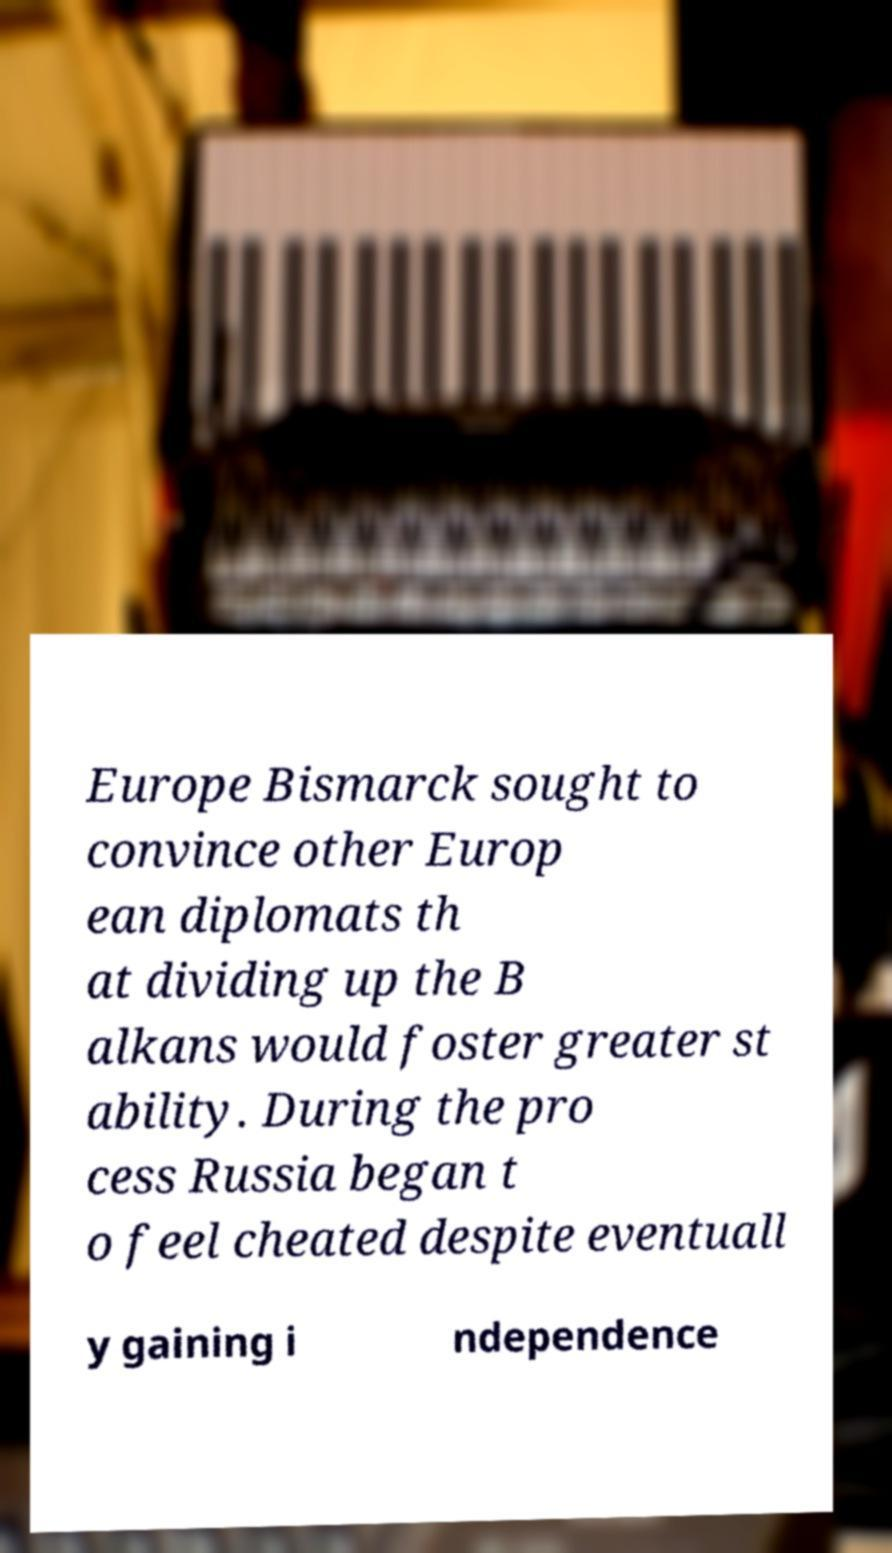Could you extract and type out the text from this image? Europe Bismarck sought to convince other Europ ean diplomats th at dividing up the B alkans would foster greater st ability. During the pro cess Russia began t o feel cheated despite eventuall y gaining i ndependence 